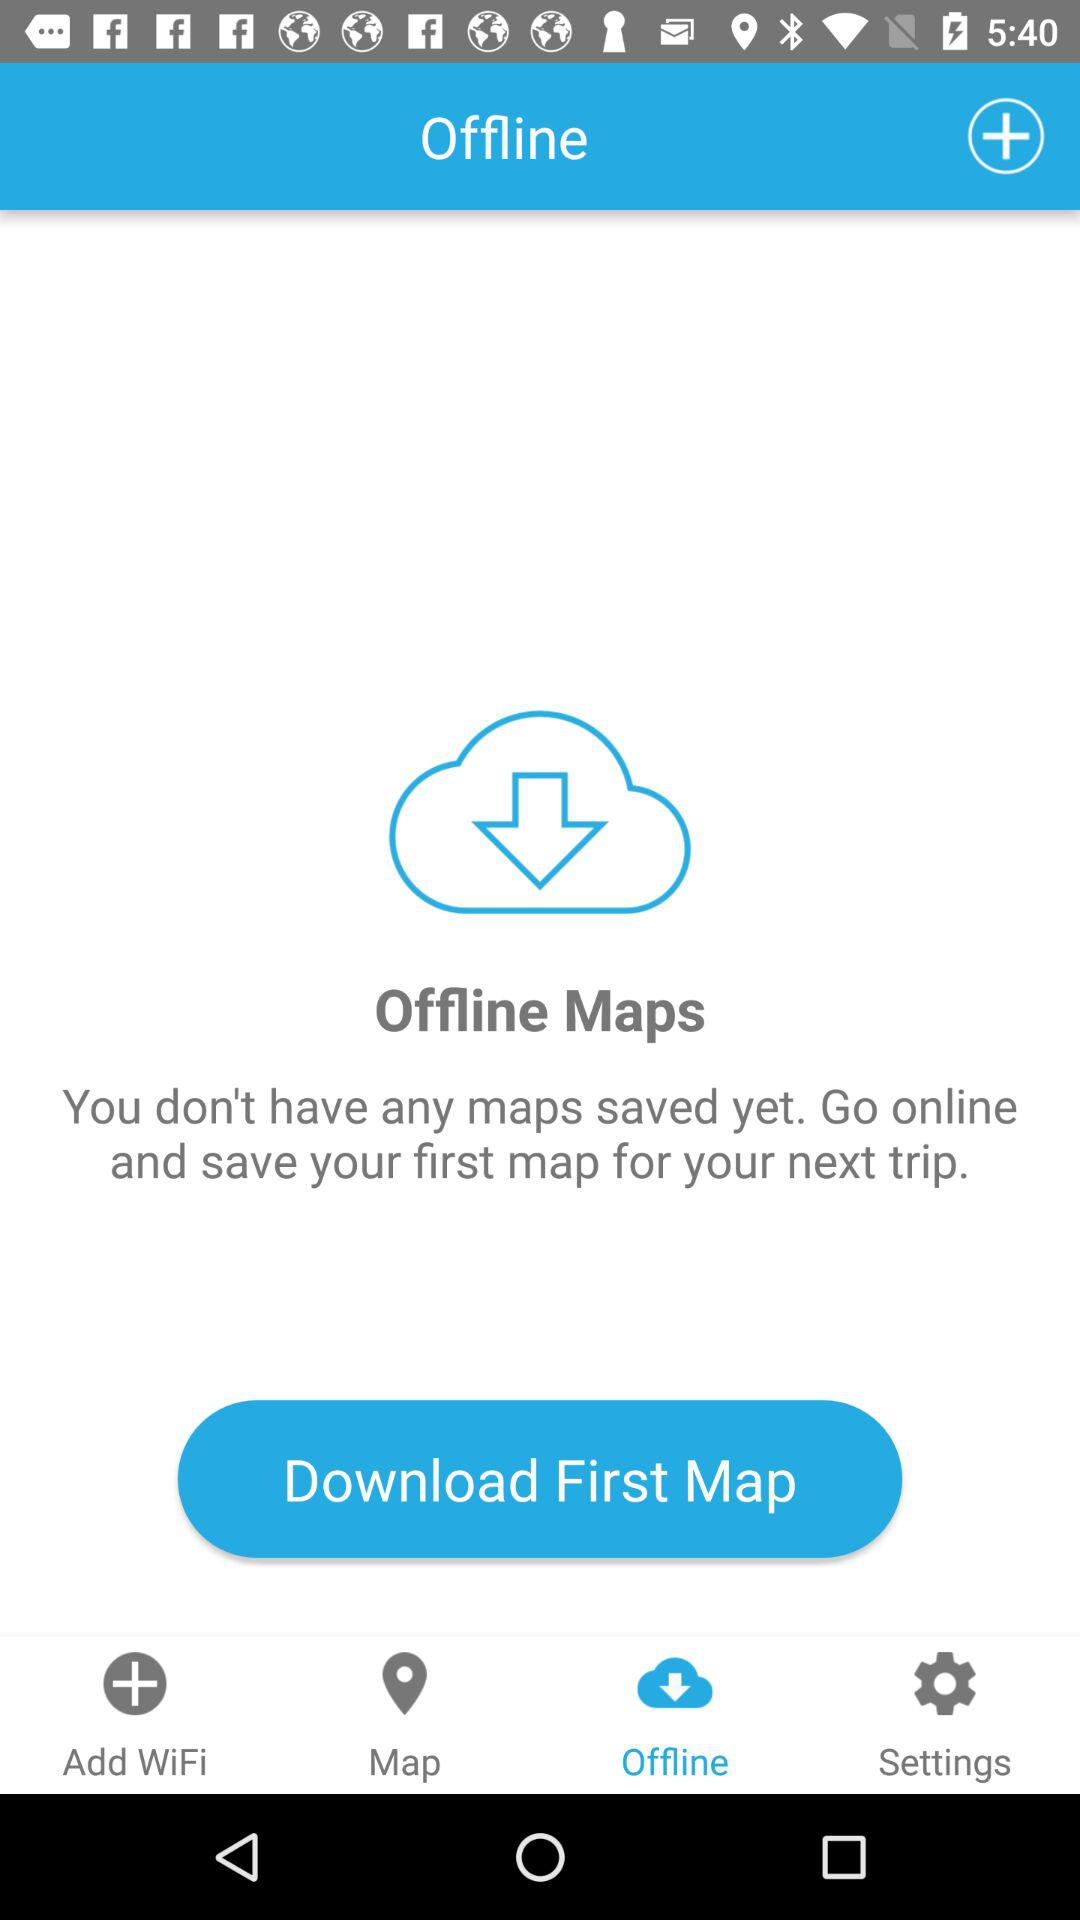On which tab of the application are we? You are on the "Offline" tab of the application. 